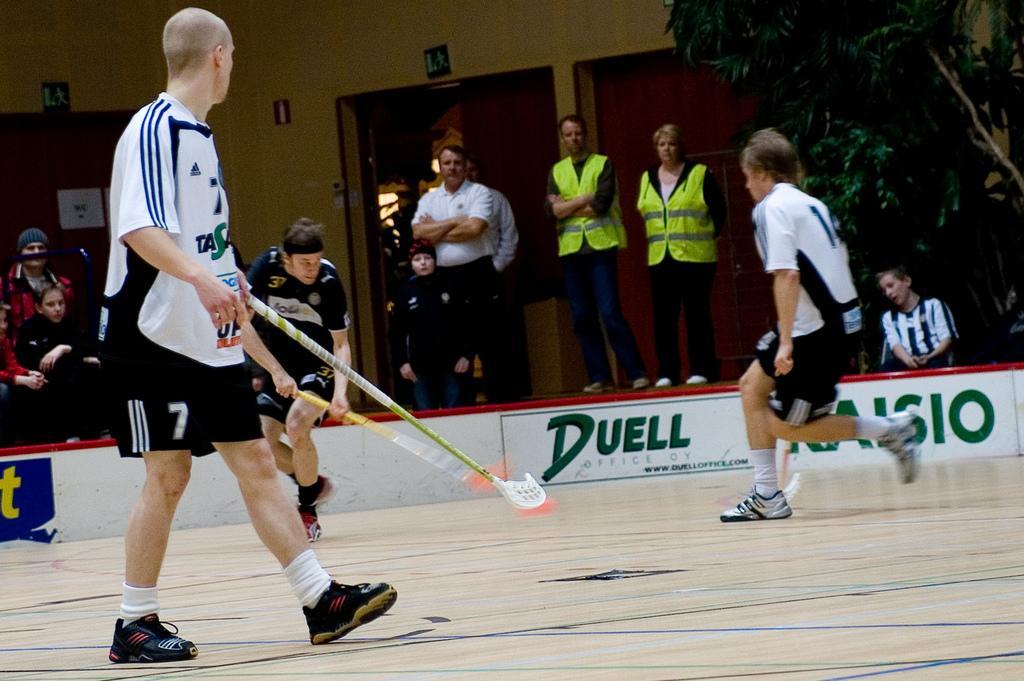Describe this image in one or two sentences. In this image, we can see a group of people. Few are sitting, standing and running. Here a person is walking. Few people are holding sticks. Background there is a wall, posters, sign boards and tree. 